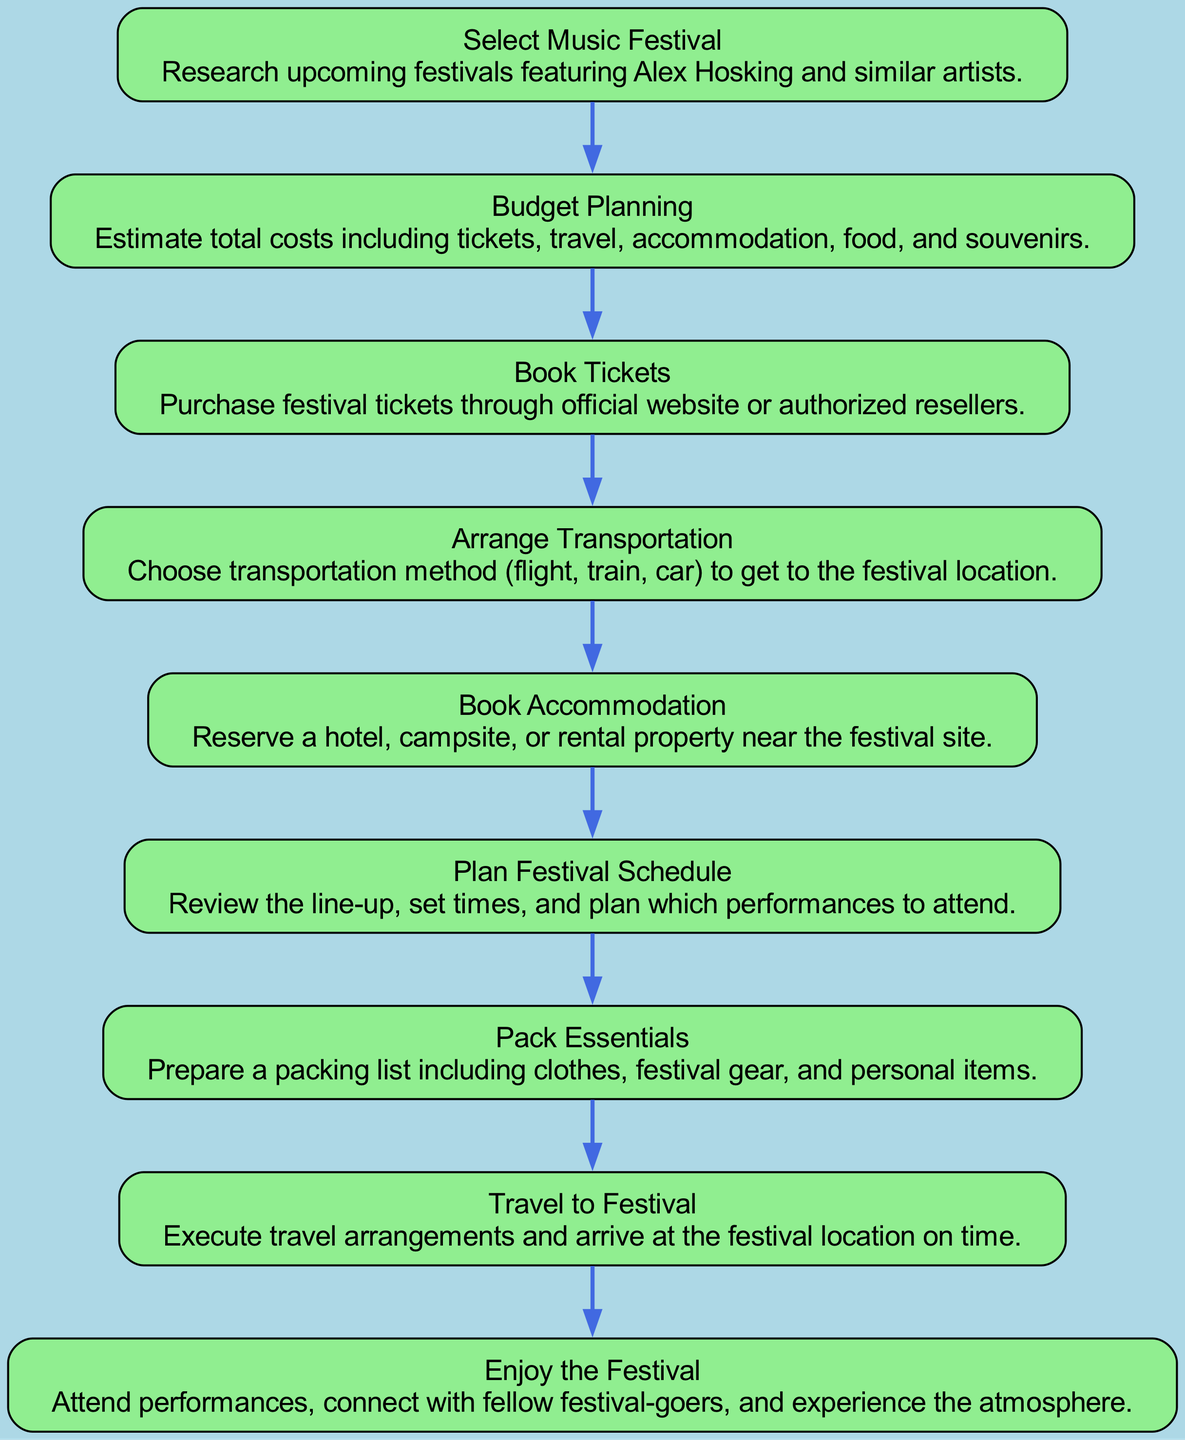What is the first step in the festival travel planning process? The first step in the process is to select a music festival, as listed at the top of the flow chart.
Answer: Select Music Festival How many steps are in the festival travel planning process? By counting the nodes in the diagram, there are a total of 9 steps in the festival travel planning process.
Answer: 9 What does the "Book Tickets" step involve? The "Book Tickets" step involves purchasing festival tickets through the official website or authorized resellers, as described in the corresponding node.
Answer: Purchase festival tickets What is the last step in the festival travel planning process? The last step listed in the flow chart is "Enjoy the Festival," indicating that the planning culminates in attending the event.
Answer: Enjoy the Festival Which step follows "Arrange Transportation"? Directly following "Arrange Transportation" in the flow chart is the "Book Accommodation" step.
Answer: Book Accommodation What is the purpose of "Plan Festival Schedule"? The purpose of this step is to review the line-up, set times, and plan which performances to attend, as defined in the diagram.
Answer: Review line-up and set times After "Budget Planning," what is the next action to take? After completing "Budget Planning," the next action is to "Book Tickets," which follows directly in the flow.
Answer: Book Tickets What key activities are included in "Pack Essentials"? "Pack Essentials" includes preparing a packing list for clothes, festival gear, and personal items.
Answer: Prepare a packing list How does "Travel to Festival" relate to the previous step? "Travel to Festival" executes the travel arrangements made in earlier steps, specifically following the logistics of booking transportation and accommodation.
Answer: Executes travel arrangements 